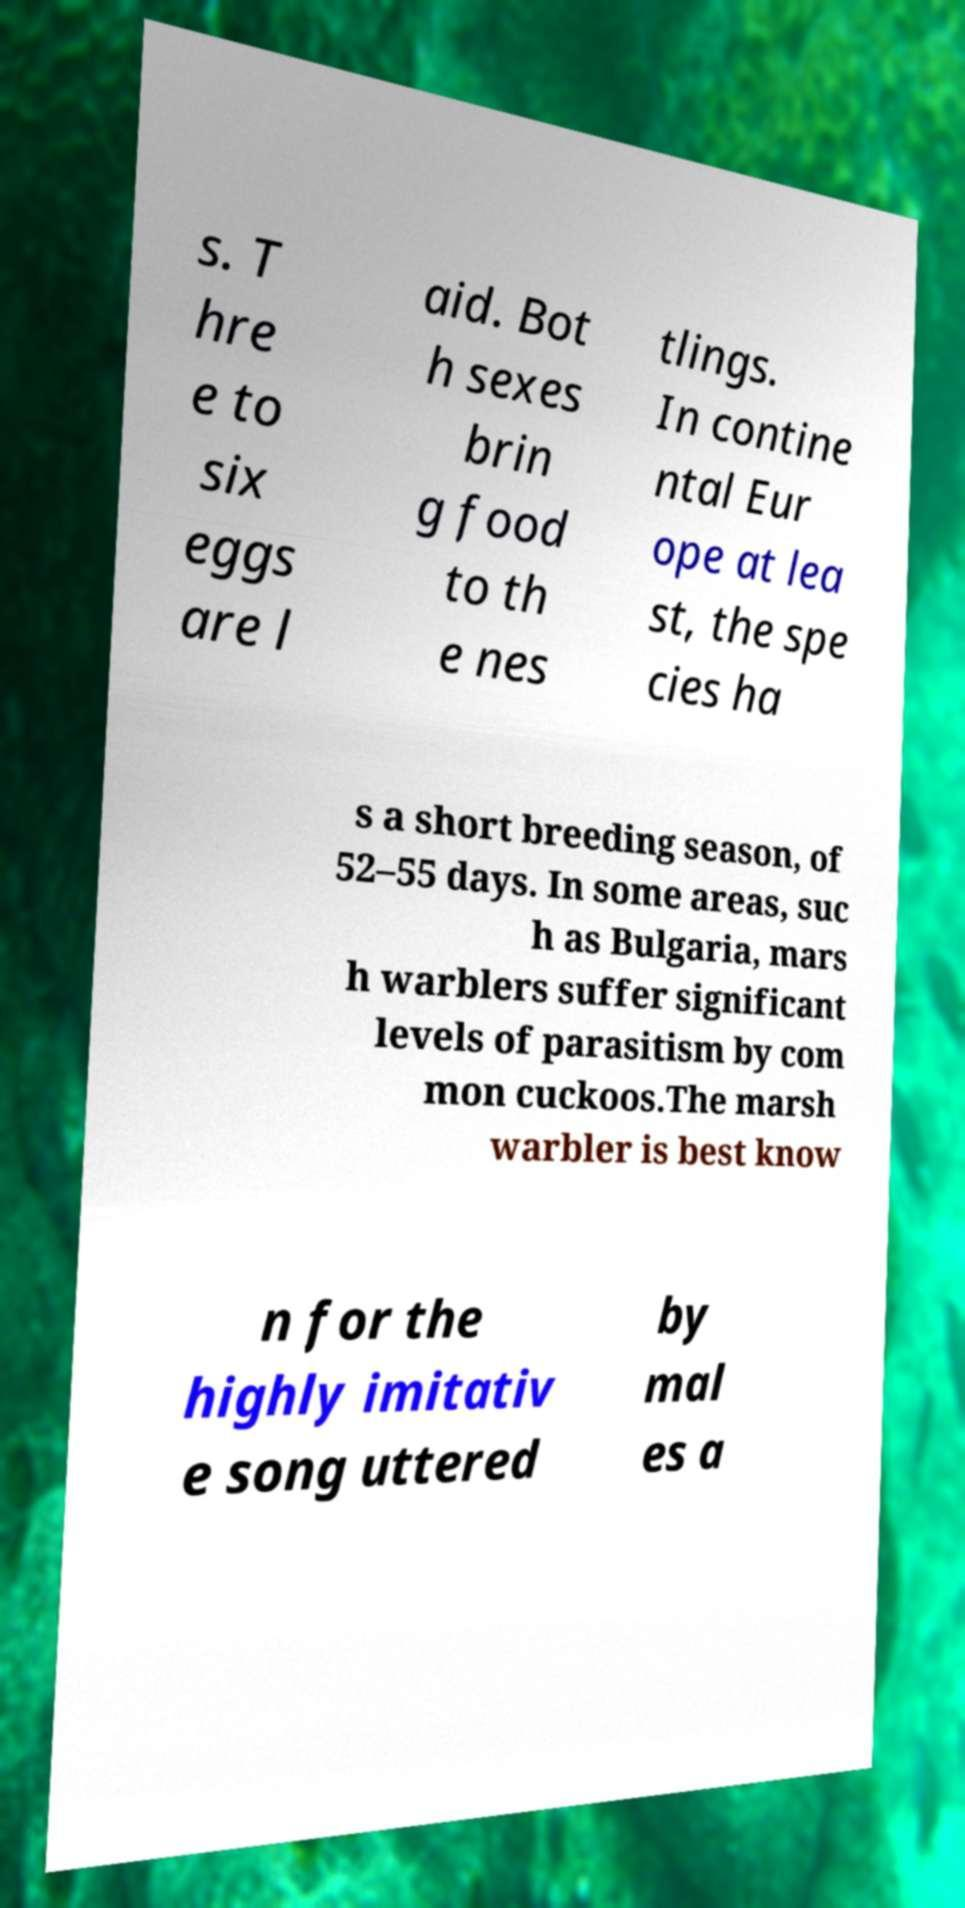Could you extract and type out the text from this image? s. T hre e to six eggs are l aid. Bot h sexes brin g food to th e nes tlings. In contine ntal Eur ope at lea st, the spe cies ha s a short breeding season, of 52–55 days. In some areas, suc h as Bulgaria, mars h warblers suffer significant levels of parasitism by com mon cuckoos.The marsh warbler is best know n for the highly imitativ e song uttered by mal es a 